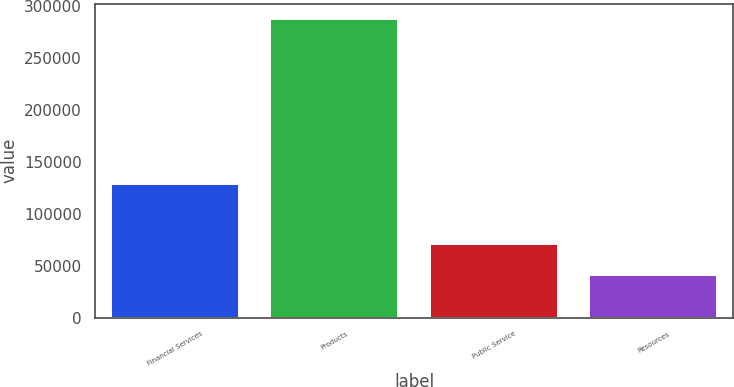Convert chart to OTSL. <chart><loc_0><loc_0><loc_500><loc_500><bar_chart><fcel>Financial Services<fcel>Products<fcel>Public Service<fcel>Resources<nl><fcel>128343<fcel>287576<fcel>71211<fcel>41401<nl></chart> 